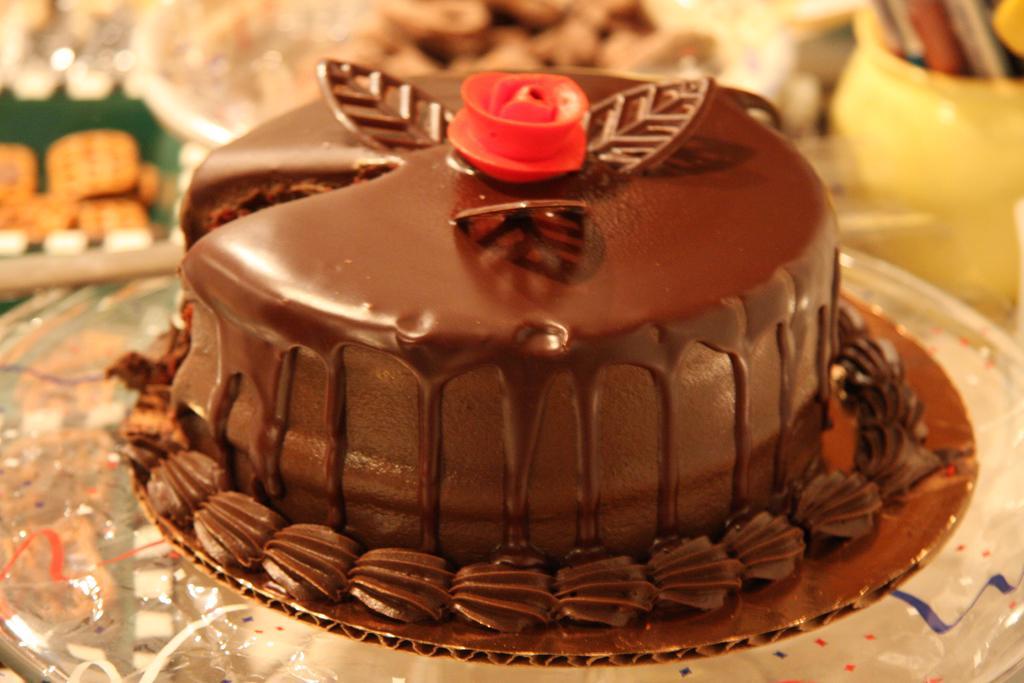Can you describe this image briefly? In the picture we can see a cake which is brown in color with cream it is placed on the glass surface and on it we can see a red color flower cream and behind it we can see some cakes. 